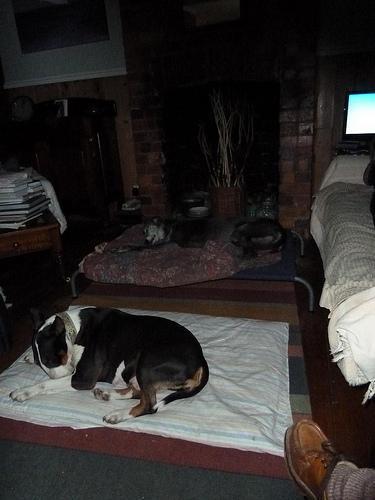How many dogs are in the photo?
Give a very brief answer. 2. 